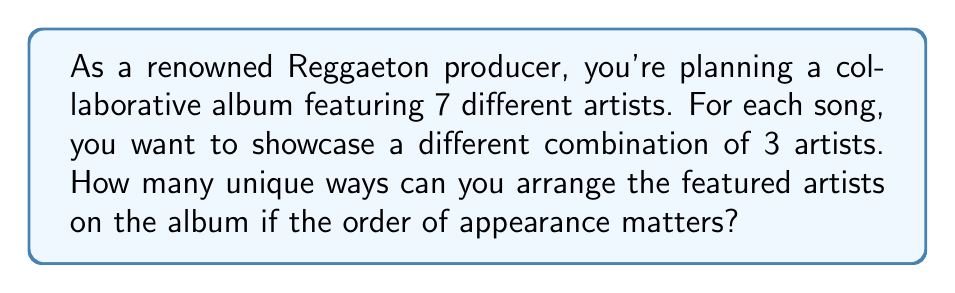Could you help me with this problem? Let's approach this step-by-step:

1) This is a permutation problem. We are selecting 3 artists out of 7, and the order matters.

2) The formula for permutations is:

   $$P(n,r) = \frac{n!}{(n-r)!}$$

   Where $n$ is the total number of items to choose from, and $r$ is the number of items being chosen.

3) In this case, $n = 7$ (total number of artists) and $r = 3$ (number of artists featured in each song).

4) Plugging these values into the formula:

   $$P(7,3) = \frac{7!}{(7-3)!} = \frac{7!}{4!}$$

5) Expanding this:

   $$\frac{7 * 6 * 5 * 4!}{4!}$$

6) The $4!$ cancels out in the numerator and denominator:

   $$7 * 6 * 5 = 210$$

Therefore, there are 210 unique ways to arrange 3 artists out of 7 for each song on the album.
Answer: 210 unique arrangements 